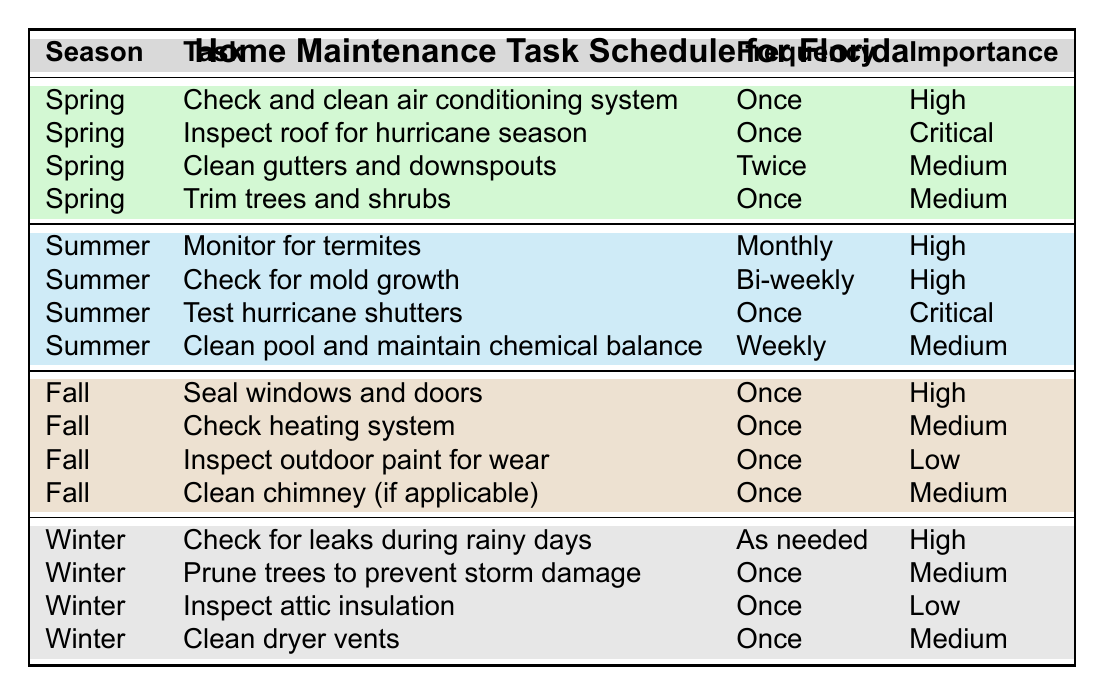What's the frequency for checking and cleaning the air conditioning system in spring? The table indicates that the frequency for checking and cleaning the air conditioning system in spring is listed as "Once".
Answer: Once How many high importance tasks are there in the summer? The summer section of the table has two tasks marked as "High" importance: "Monitor for termites" and "Check for mold growth". Therefore, there are two high importance tasks in the summer.
Answer: 2 Is it true that every fall task is performed only once? Reviewing the fall tasks, all tasks including "Seal windows and doors," "Check heating system," "Inspect outdoor paint for wear," and "Clean chimney (if applicable)" are marked as "Once". Thus, it is true that every fall task is performed only once.
Answer: Yes What is the total number of medium importance tasks across all seasons? In spring, there are 2 medium importance tasks. In summer, there is 1 medium task. In fall, there are 2 medium tasks. In winter, there are 2 medium tasks. Summing these gives 2 + 1 + 2 + 2 = 7 medium importance tasks in total.
Answer: 7 Which season has the highest number of critical importance tasks and what are they? In reviewing the seasons: spring has 1 critical task ("Inspect roof for hurricane season"), while summer also has 1 critical task ("Test hurricane shutters"). Both seasons have the same number of critical importance tasks, with neither having more than the other.
Answer: Spring and Summer In how many seasons is the task of inspecting attic insulation scheduled? By examining the table, the task of inspecting attic insulation is scheduled in winter only, as it appears in that season. Therefore, it is scheduled in just one season.
Answer: 1 